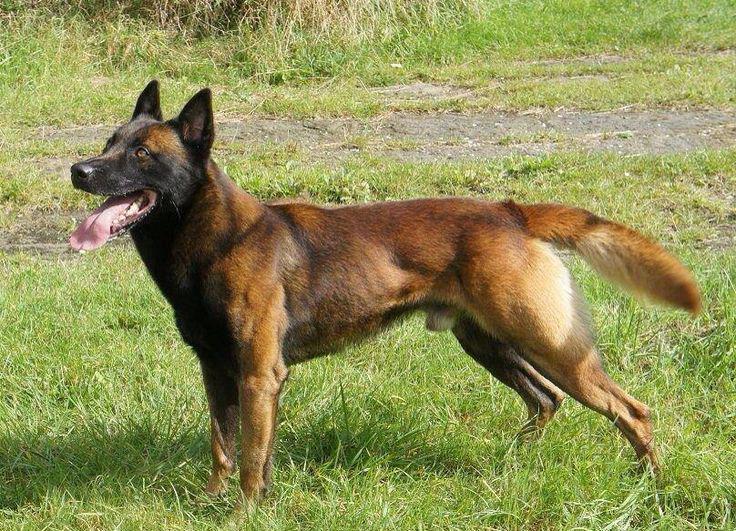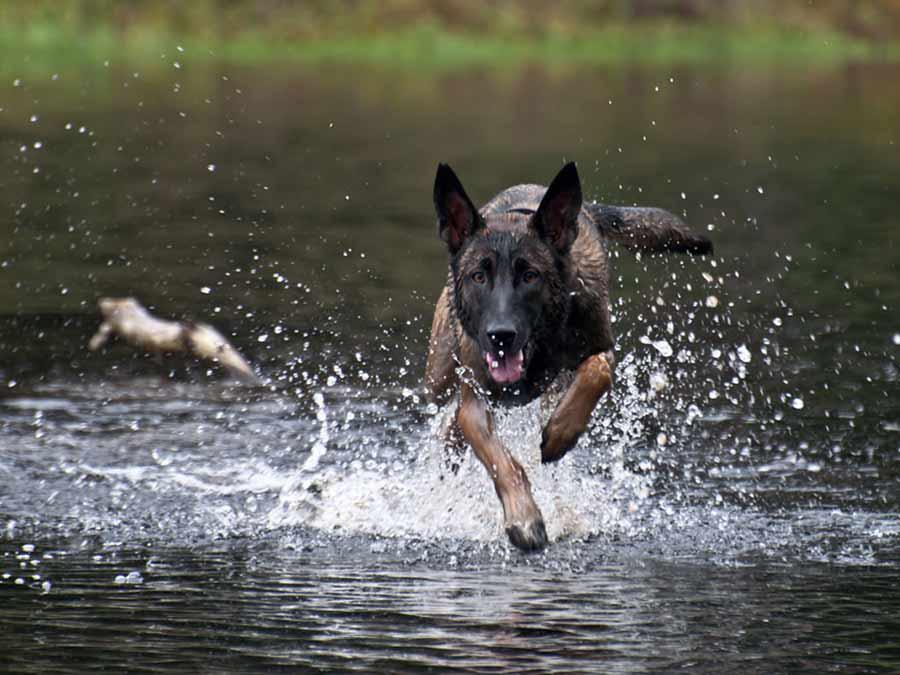The first image is the image on the left, the second image is the image on the right. Evaluate the accuracy of this statement regarding the images: "There is exactly one human interacting with a dog.". Is it true? Answer yes or no. No. 